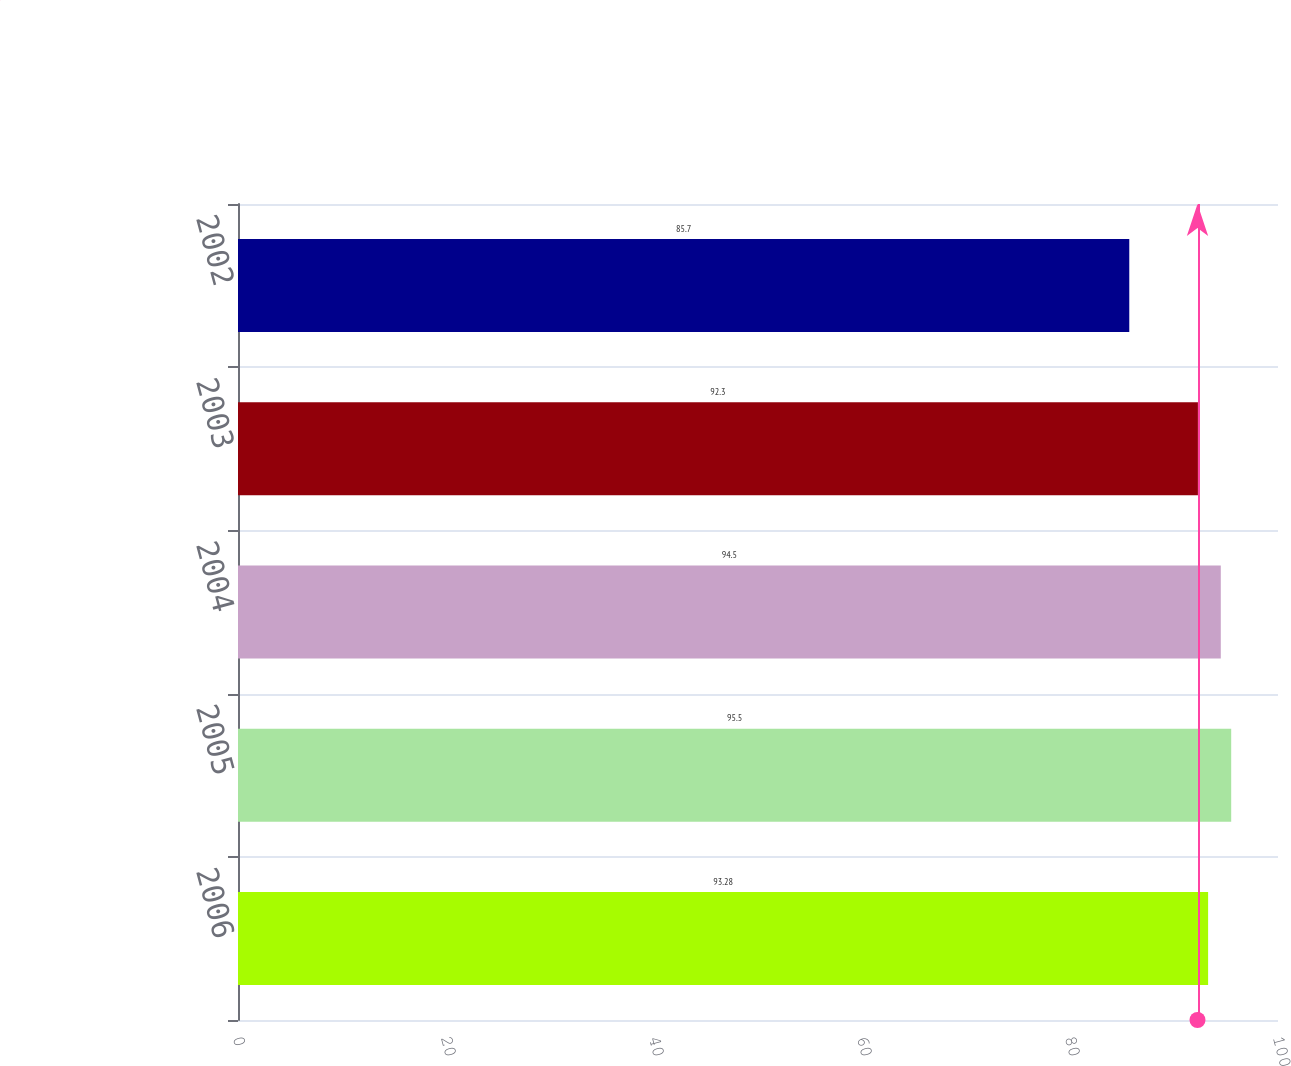Convert chart. <chart><loc_0><loc_0><loc_500><loc_500><bar_chart><fcel>2006<fcel>2005<fcel>2004<fcel>2003<fcel>2002<nl><fcel>93.28<fcel>95.5<fcel>94.5<fcel>92.3<fcel>85.7<nl></chart> 